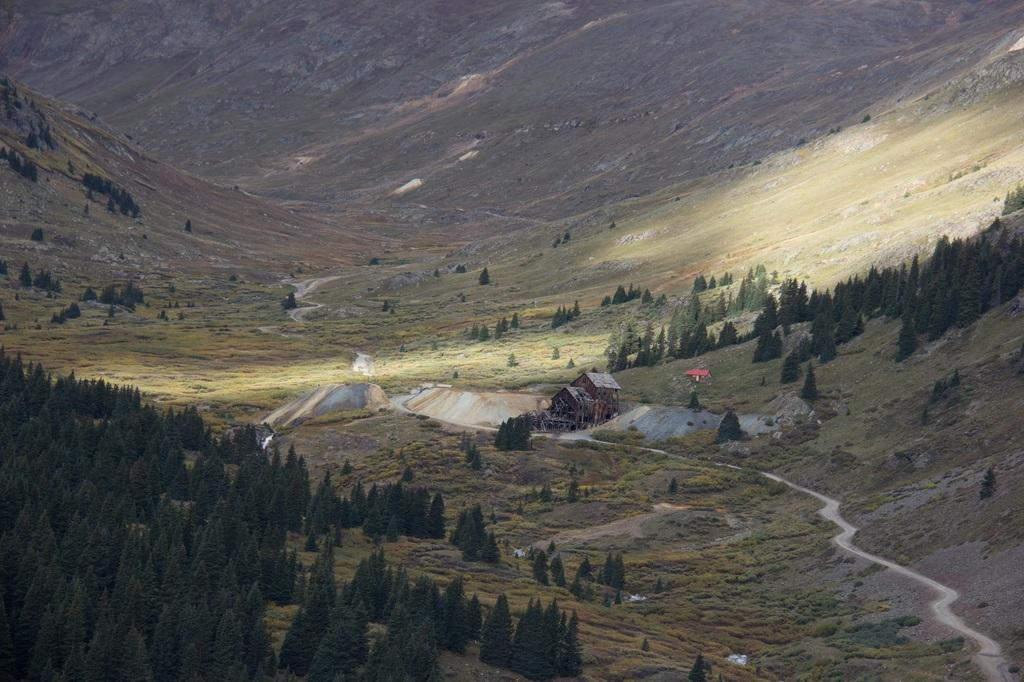What type of structures can be seen in the image? There are houses in the image. What natural elements are present in the image? There are rocks, mountains, and trees in the image. Where is the man sleeping on the bed in the image? There is no man sleeping on a bed in the image; it only features houses, rocks, mountains, and trees. 